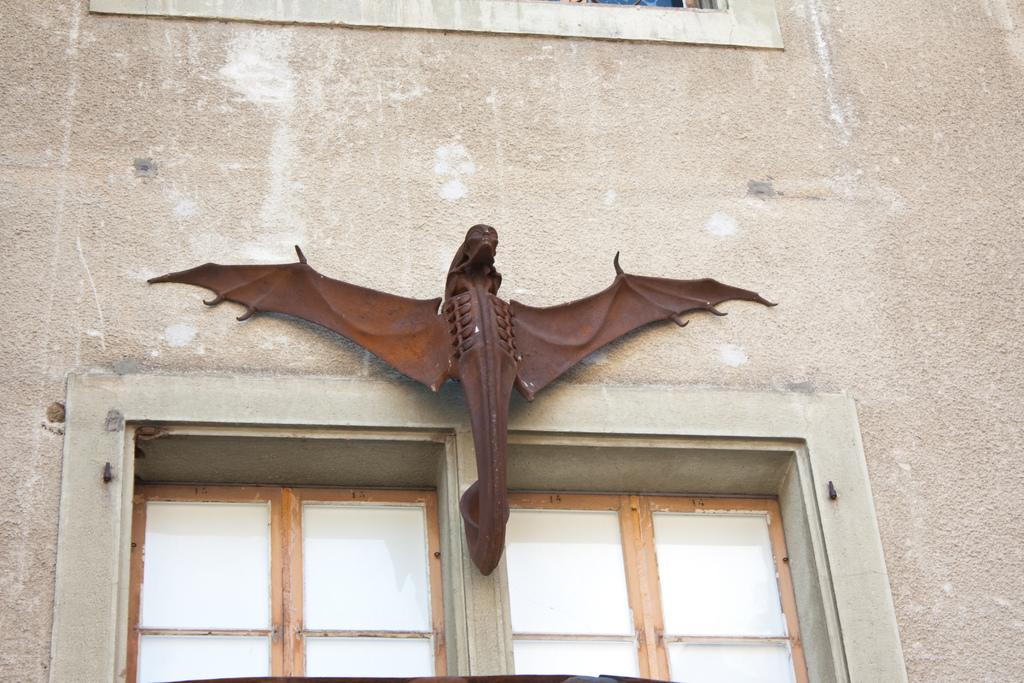What is depicted as a statue in the image? There is a statue of an animal in the image. How is the statue positioned in relation to the wall? The statue is attached to a wall. What architectural features are present under the statue? There are two windows under the statue. Can you see any blood on the statue in the image? There is no blood present on the statue in the image. 